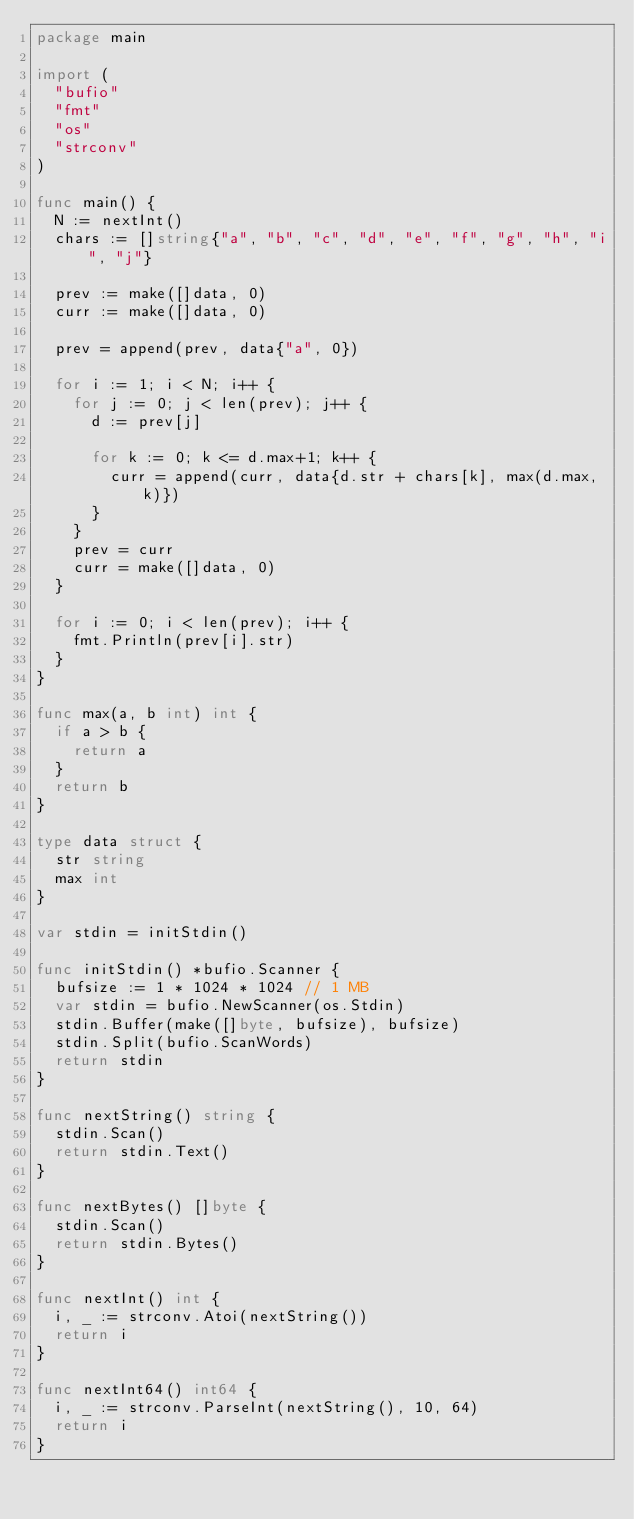<code> <loc_0><loc_0><loc_500><loc_500><_Go_>package main

import (
	"bufio"
	"fmt"
	"os"
	"strconv"
)

func main() {
	N := nextInt()
	chars := []string{"a", "b", "c", "d", "e", "f", "g", "h", "i", "j"}

	prev := make([]data, 0)
	curr := make([]data, 0)

	prev = append(prev, data{"a", 0})

	for i := 1; i < N; i++ {
		for j := 0; j < len(prev); j++ {
			d := prev[j]

			for k := 0; k <= d.max+1; k++ {
				curr = append(curr, data{d.str + chars[k], max(d.max, k)})
			}
		}
		prev = curr
		curr = make([]data, 0)
	}

	for i := 0; i < len(prev); i++ {
		fmt.Println(prev[i].str)
	}
}

func max(a, b int) int {
	if a > b {
		return a
	}
	return b
}

type data struct {
	str string
	max int
}

var stdin = initStdin()

func initStdin() *bufio.Scanner {
	bufsize := 1 * 1024 * 1024 // 1 MB
	var stdin = bufio.NewScanner(os.Stdin)
	stdin.Buffer(make([]byte, bufsize), bufsize)
	stdin.Split(bufio.ScanWords)
	return stdin
}

func nextString() string {
	stdin.Scan()
	return stdin.Text()
}

func nextBytes() []byte {
	stdin.Scan()
	return stdin.Bytes()
}

func nextInt() int {
	i, _ := strconv.Atoi(nextString())
	return i
}

func nextInt64() int64 {
	i, _ := strconv.ParseInt(nextString(), 10, 64)
	return i
}
</code> 